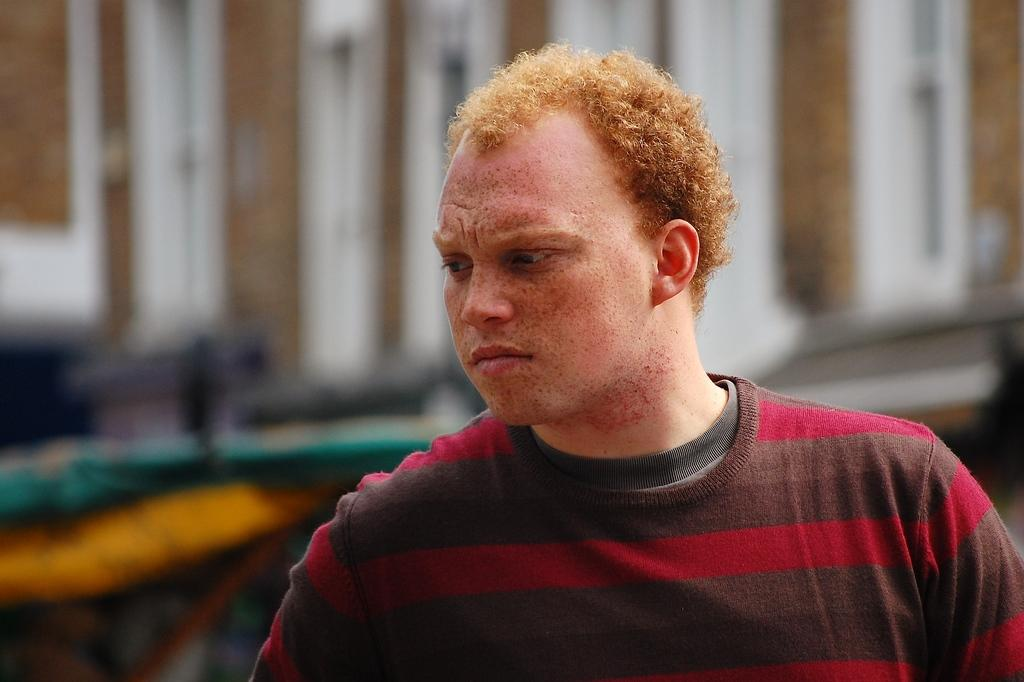Who is present in the image? There is a man in the image. Can you describe the background of the image? The background of the image is blurry. Can you see any fairies flying around the man in the image? There are no fairies present in the image. What part of the man's body is missing in the image? The image does not show any missing body parts; the man is complete. 